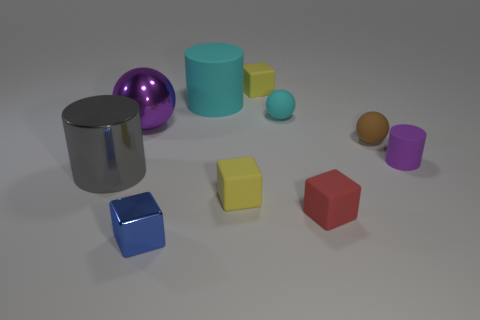Subtract all blue blocks. How many blocks are left? 3 Subtract 1 blocks. How many blocks are left? 3 Subtract all metallic cubes. How many cubes are left? 3 Subtract all brown cubes. Subtract all red cylinders. How many cubes are left? 4 Subtract all cylinders. How many objects are left? 7 Add 2 brown spheres. How many brown spheres are left? 3 Add 6 blocks. How many blocks exist? 10 Subtract 0 green spheres. How many objects are left? 10 Subtract all tiny blue metallic balls. Subtract all tiny cyan matte spheres. How many objects are left? 9 